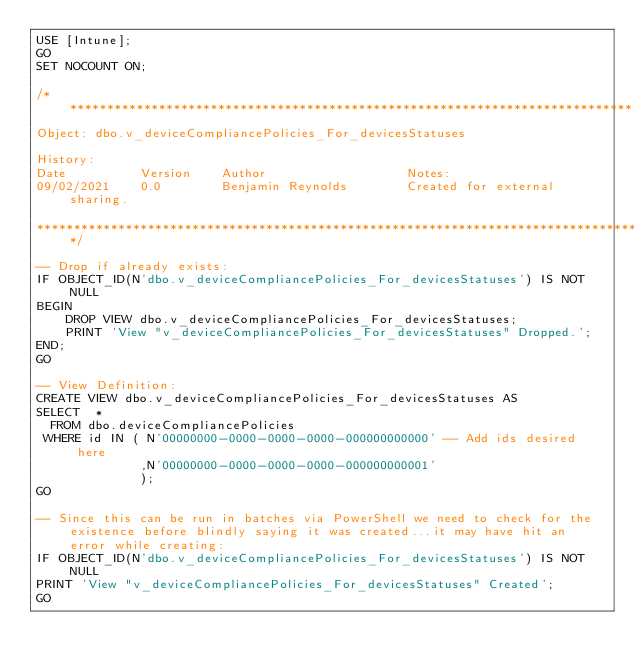Convert code to text. <code><loc_0><loc_0><loc_500><loc_500><_SQL_>USE [Intune];
GO
SET NOCOUNT ON;

/***************************************************************************************************************************
Object: dbo.v_deviceCompliancePolicies_For_devicesStatuses

History:
Date          Version    Author                   Notes:
09/02/2021    0.0        Benjamin Reynolds        Created for external sharing.

***************************************************************************************************************************/

-- Drop if already exists:
IF OBJECT_ID(N'dbo.v_deviceCompliancePolicies_For_devicesStatuses') IS NOT NULL
BEGIN
    DROP VIEW dbo.v_deviceCompliancePolicies_For_devicesStatuses;
    PRINT 'View "v_deviceCompliancePolicies_For_devicesStatuses" Dropped.';
END;
GO

-- View Definition:
CREATE VIEW dbo.v_deviceCompliancePolicies_For_devicesStatuses AS
SELECT  *
  FROM dbo.deviceCompliancePolicies
 WHERE id IN ( N'00000000-0000-0000-0000-000000000000' -- Add ids desired here
              ,N'00000000-0000-0000-0000-000000000001'
              );
GO

-- Since this can be run in batches via PowerShell we need to check for the existence before blindly saying it was created...it may have hit an error while creating:
IF OBJECT_ID(N'dbo.v_deviceCompliancePolicies_For_devicesStatuses') IS NOT NULL
PRINT 'View "v_deviceCompliancePolicies_For_devicesStatuses" Created';
GO</code> 